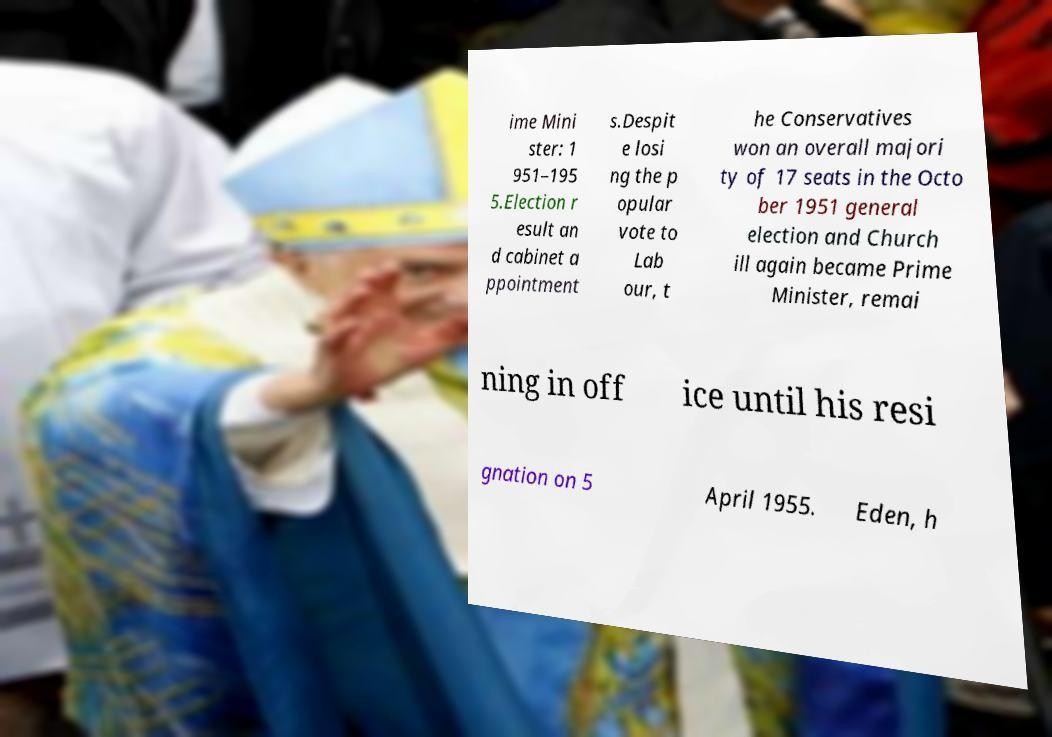For documentation purposes, I need the text within this image transcribed. Could you provide that? ime Mini ster: 1 951–195 5.Election r esult an d cabinet a ppointment s.Despit e losi ng the p opular vote to Lab our, t he Conservatives won an overall majori ty of 17 seats in the Octo ber 1951 general election and Church ill again became Prime Minister, remai ning in off ice until his resi gnation on 5 April 1955. Eden, h 